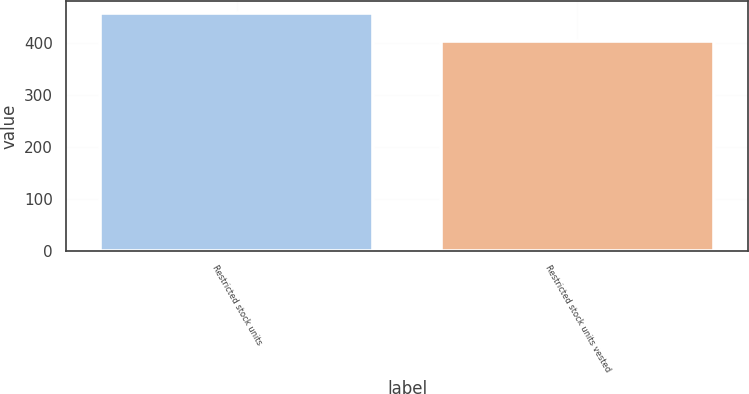Convert chart. <chart><loc_0><loc_0><loc_500><loc_500><bar_chart><fcel>Restricted stock units<fcel>Restricted stock units vested<nl><fcel>457.4<fcel>404.3<nl></chart> 